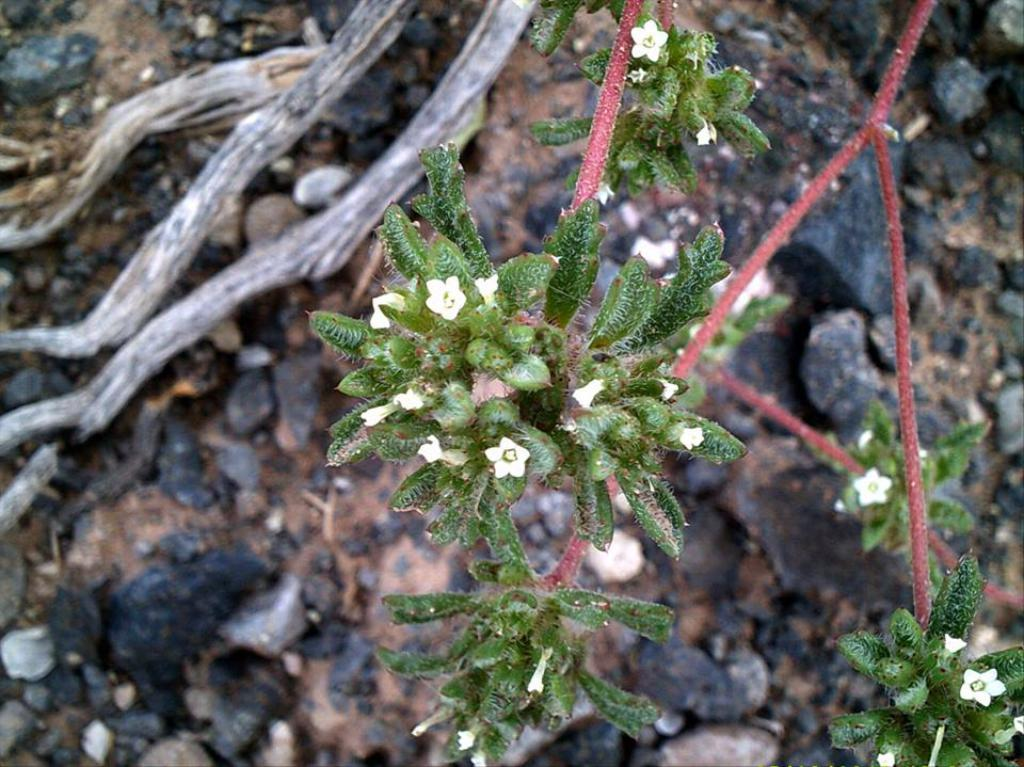What type of flowers can be seen in the image? There are small white color flowers in the image. What color are the leaves in the image? The leaves in the image are green. What material is visible in the background of the image? There is wood in the background of the image. What can be found on the ground in the background of the image? There are stones on the ground in the background of the image. What type of coat is the crow wearing in the image? There is no crow present in the image, and therefore no coat or any other clothing item can be observed. 